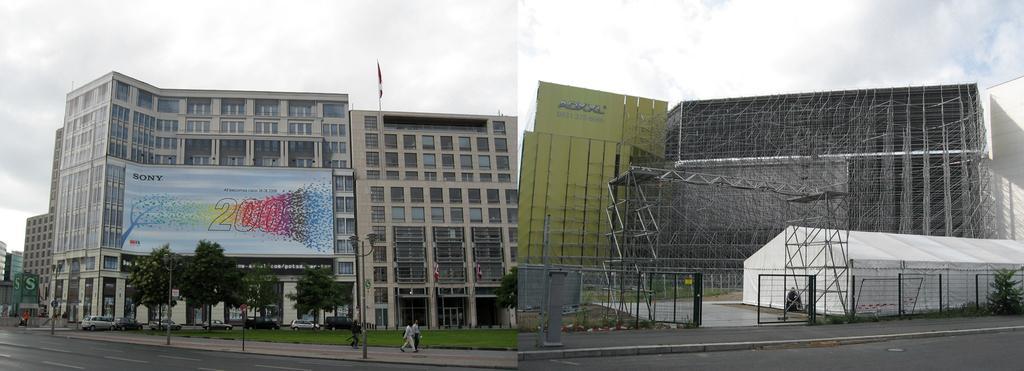Could you give a brief overview of what you see in this image? In this picture we can see building with windows and a banner on that building in front of the building we can see cars parked, grass, road beside to this road we have poles and above the building we have a sky and here the building is in a construction stage same building before the construction and here the sky is so cloudy. 